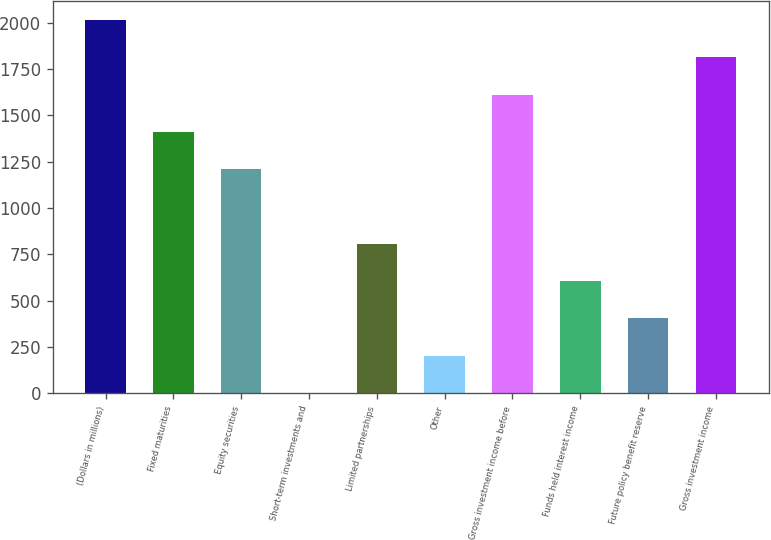Convert chart. <chart><loc_0><loc_0><loc_500><loc_500><bar_chart><fcel>(Dollars in millions)<fcel>Fixed maturities<fcel>Equity securities<fcel>Short-term investments and<fcel>Limited partnerships<fcel>Other<fcel>Gross investment income before<fcel>Funds held interest income<fcel>Future policy benefit reserve<fcel>Gross investment income<nl><fcel>2015<fcel>1410.86<fcel>1209.48<fcel>1.2<fcel>806.72<fcel>202.58<fcel>1612.24<fcel>605.34<fcel>403.96<fcel>1813.62<nl></chart> 